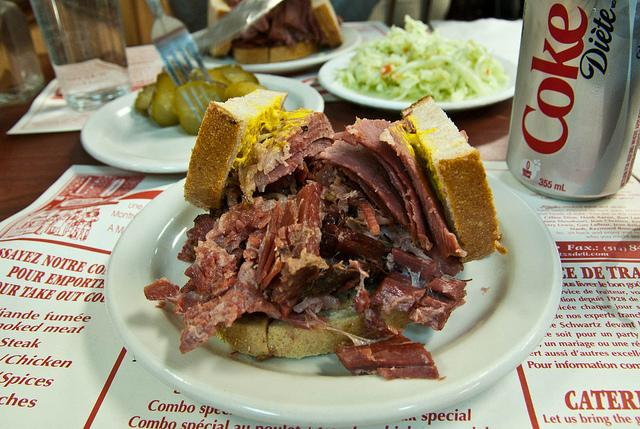What type of sandwich is this? corned beef 